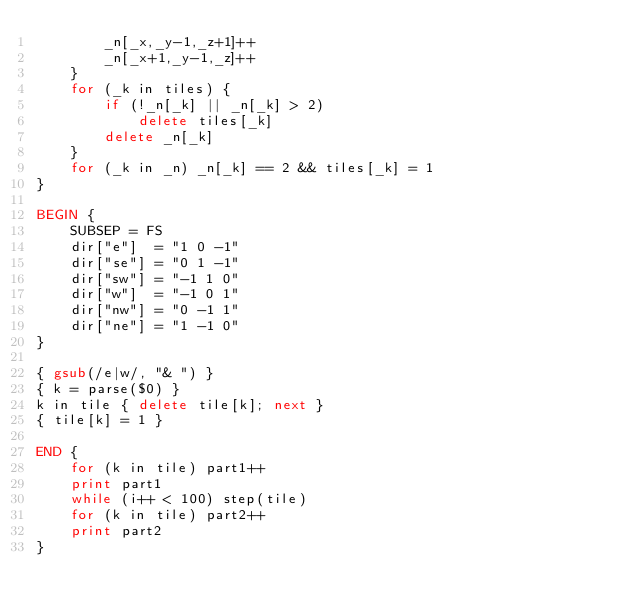Convert code to text. <code><loc_0><loc_0><loc_500><loc_500><_Awk_>		_n[_x,_y-1,_z+1]++
		_n[_x+1,_y-1,_z]++
	}
	for (_k in tiles) {
		if (!_n[_k] || _n[_k] > 2)
			delete tiles[_k]
		delete _n[_k]
	}
	for (_k in _n) _n[_k] == 2 && tiles[_k] = 1
}

BEGIN {
	SUBSEP = FS
	dir["e"]  = "1 0 -1"
	dir["se"] = "0 1 -1"
	dir["sw"] = "-1 1 0"
	dir["w"]  = "-1 0 1"
	dir["nw"] = "0 -1 1"
	dir["ne"] = "1 -1 0"
}

{ gsub(/e|w/, "& ") }
{ k = parse($0) }
k in tile { delete tile[k]; next }
{ tile[k] = 1 }

END {
	for (k in tile) part1++
	print part1
	while (i++ < 100) step(tile)
	for (k in tile) part2++
	print part2
}
</code> 